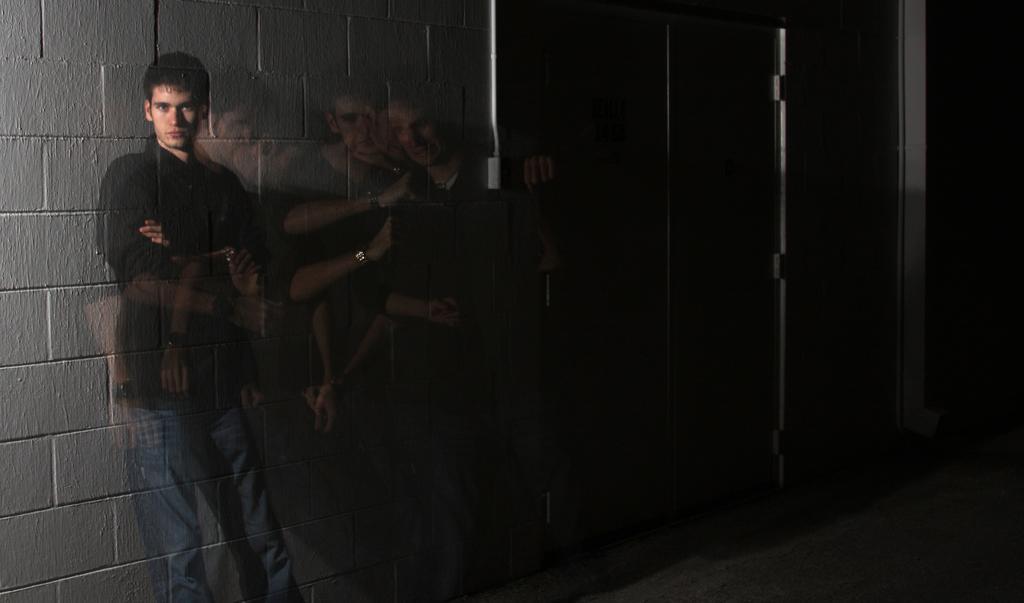Could you give a brief overview of what you see in this image? In this image there is a man in the middle who is lying on the wall by folding his hand. On the right side there are reflections of his image. 